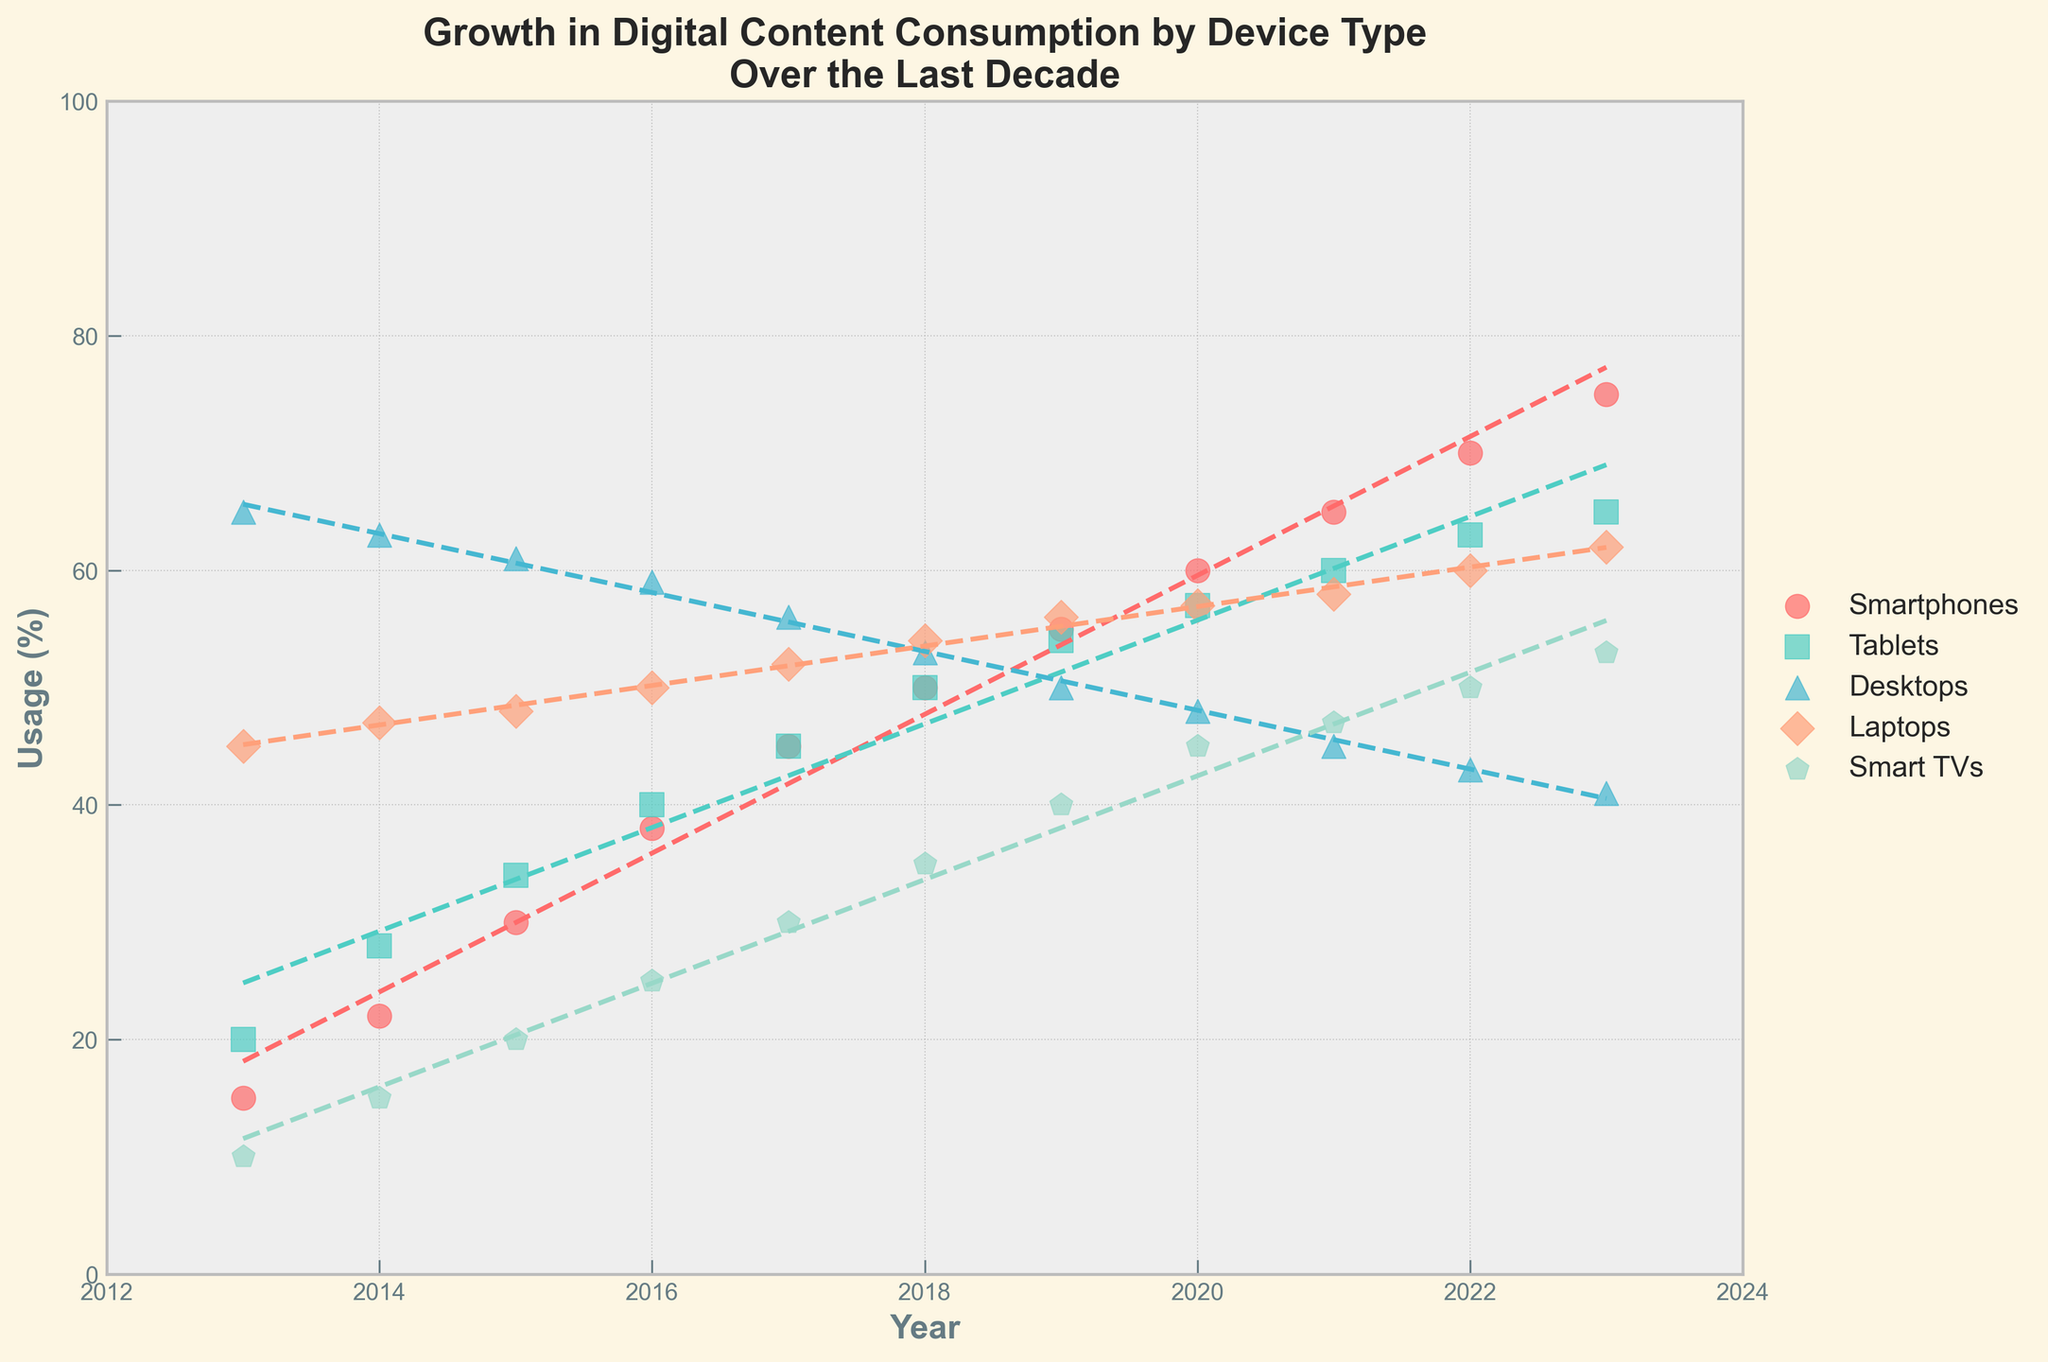What is the title of the figure? The title is located at the top of the figure and summarizes the content of the plot.
Answer: Growth in Digital Content Consumption by Device Type Over the Last Decade What does the x-axis represent? The x-axis typically represents the independent variable, identifiable by its labels. In this case, the x-axis is labeled "Year."
Answer: Year Which device type has shown a consistent increase in digital content consumption over the entire decade? By observing the trend lines, identify the device type whose usage consistently increases from 2013 to 2023.
Answer: Smartphones What is the usage percentage of tablets in 2019? Locate the data point for tablets in the year 2019 on the plot to find the corresponding usage percentage.
Answer: 54% Which device type had the highest usage percentage in 2013, and what was that percentage? To find this, compare all the data points for the year 2013, looking for the maximum value and the corresponding device.
Answer: Desktops, 65% How has the usage of desktops changed from 2013 to 2023? Analyze the trend line for desktops over the years from 2013 to 2023 to understand the change in usage percentage.
Answer: Decreased from 65% to 41% What is the average usage percentage of smart TVs over the decade? Sum the data points for smart TVs from 2013 to 2023 and divide by the number of years (11).
Answer: 30% Which device type had the smallest increase in usage over the decade? Calculate the difference in usage from 2013 to 2023 for each device and identify the smallest increase.
Answer: Desktops How does the trend line for laptops compare to that for desktops? Compare the slopes and general directions of the trend lines for laptops and desktops to determine their relationship over the decade.
Answer: Laptops show a slight increase while desktops show a decrease What year did tablets surpass desktops in terms of usage percentage? Find the intersection point of the data points or trend lines for tablets and desktops, where tablets' usage exceeded desktops'.
Answer: 2020 